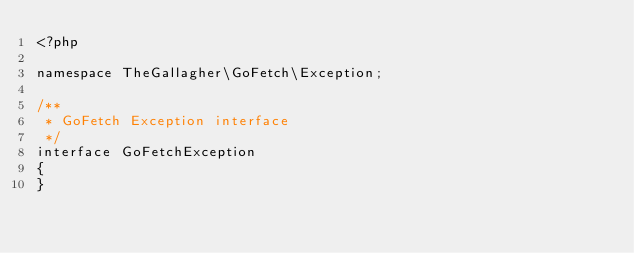<code> <loc_0><loc_0><loc_500><loc_500><_PHP_><?php

namespace TheGallagher\GoFetch\Exception;

/**
 * GoFetch Exception interface
 */
interface GoFetchException
{
}</code> 